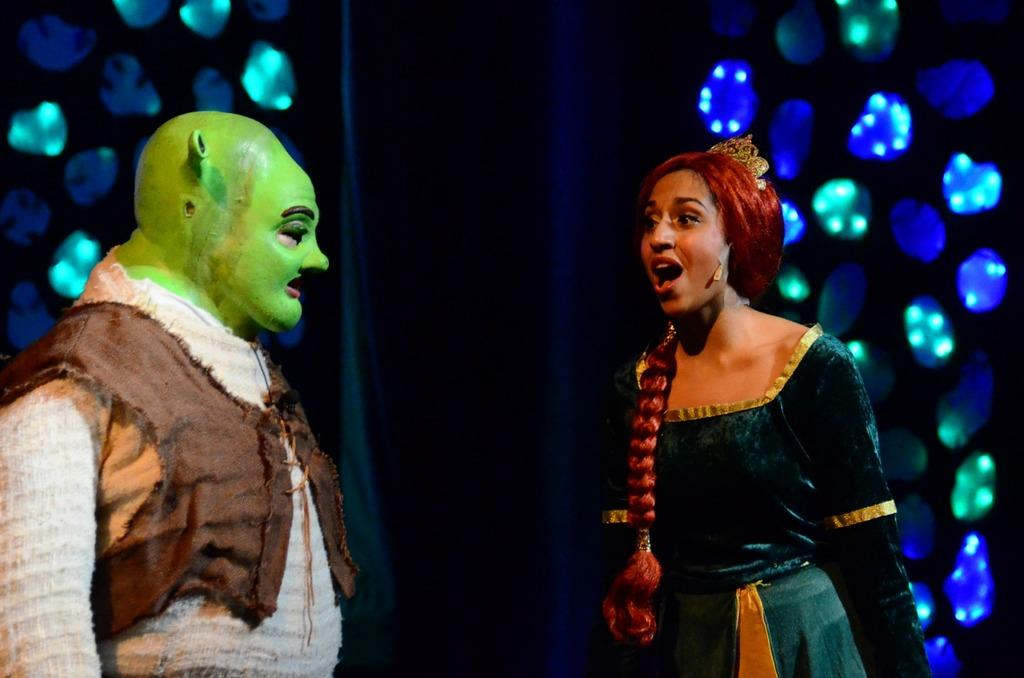How many people are present in the image? There are two people in the image. What are the people wearing? The people are wearing fancy dresses. What can be seen in the background of the image? There is a dark background in the image. What else is visible in the image besides the people? There are lights visible in the image. What type of drink is the person holding in their chin in the image? There is no person holding a drink in their chin in the image. The image only shows two people wearing fancy dresses with a dark background and visible lights. 